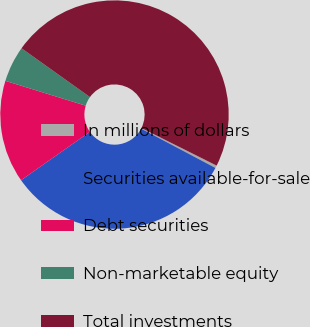Convert chart to OTSL. <chart><loc_0><loc_0><loc_500><loc_500><pie_chart><fcel>In millions of dollars<fcel>Securities available-for-sale<fcel>Debt securities<fcel>Non-marketable equity<fcel>Total investments<nl><fcel>0.37%<fcel>32.51%<fcel>14.51%<fcel>5.09%<fcel>47.51%<nl></chart> 